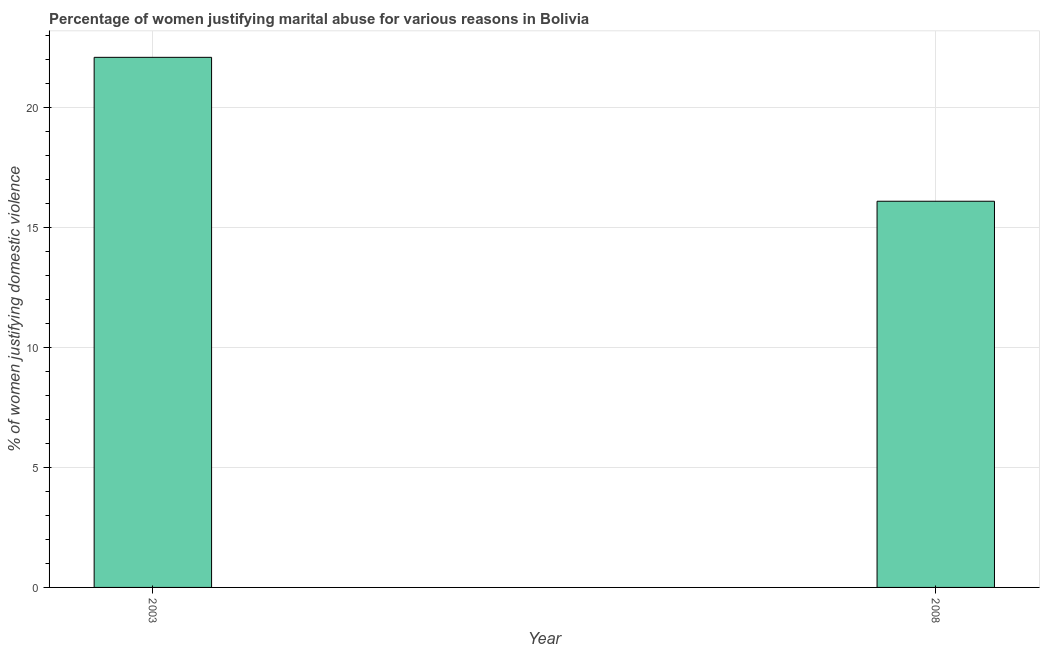Does the graph contain grids?
Offer a very short reply. Yes. What is the title of the graph?
Make the answer very short. Percentage of women justifying marital abuse for various reasons in Bolivia. What is the label or title of the X-axis?
Provide a short and direct response. Year. What is the label or title of the Y-axis?
Offer a terse response. % of women justifying domestic violence. What is the percentage of women justifying marital abuse in 2003?
Ensure brevity in your answer.  22.1. Across all years, what is the maximum percentage of women justifying marital abuse?
Give a very brief answer. 22.1. Across all years, what is the minimum percentage of women justifying marital abuse?
Offer a very short reply. 16.1. In which year was the percentage of women justifying marital abuse maximum?
Provide a succinct answer. 2003. What is the sum of the percentage of women justifying marital abuse?
Your answer should be very brief. 38.2. What is the median percentage of women justifying marital abuse?
Offer a very short reply. 19.1. In how many years, is the percentage of women justifying marital abuse greater than 12 %?
Offer a very short reply. 2. Do a majority of the years between 2003 and 2008 (inclusive) have percentage of women justifying marital abuse greater than 3 %?
Give a very brief answer. Yes. What is the ratio of the percentage of women justifying marital abuse in 2003 to that in 2008?
Keep it short and to the point. 1.37. In how many years, is the percentage of women justifying marital abuse greater than the average percentage of women justifying marital abuse taken over all years?
Your answer should be very brief. 1. Are all the bars in the graph horizontal?
Offer a very short reply. No. What is the % of women justifying domestic violence in 2003?
Your answer should be very brief. 22.1. What is the % of women justifying domestic violence in 2008?
Provide a succinct answer. 16.1. What is the difference between the % of women justifying domestic violence in 2003 and 2008?
Offer a terse response. 6. What is the ratio of the % of women justifying domestic violence in 2003 to that in 2008?
Keep it short and to the point. 1.37. 